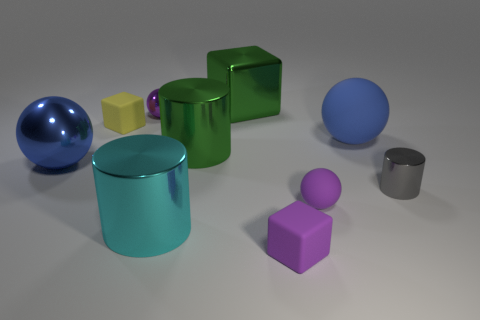What shape is the small gray thing that is the same material as the big green cylinder?
Provide a succinct answer. Cylinder. Is there a tiny block of the same color as the tiny metal cylinder?
Give a very brief answer. No. What number of shiny objects are spheres or purple objects?
Keep it short and to the point. 2. How many tiny balls are behind the big blue object that is to the right of the yellow matte object?
Keep it short and to the point. 1. What number of spheres have the same material as the yellow block?
Your response must be concise. 2. How many tiny objects are either metallic things or cyan metal balls?
Provide a succinct answer. 2. What is the shape of the small matte object that is right of the large green cube and behind the large cyan object?
Offer a very short reply. Sphere. Are the green cube and the small gray cylinder made of the same material?
Keep it short and to the point. Yes. The shiny ball that is the same size as the metallic cube is what color?
Ensure brevity in your answer.  Blue. The sphere that is both in front of the big green metallic cylinder and to the right of the green metal cylinder is what color?
Your answer should be compact. Purple. 